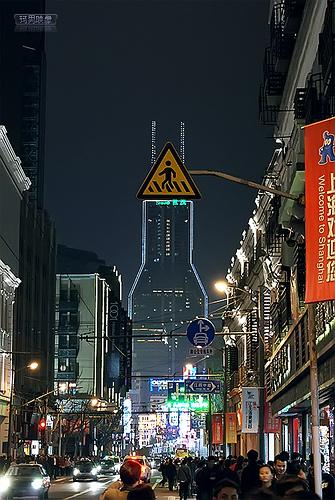Identify one unique feature or color of the sky in the image. The sky is dark blue. State the color and type of the sign on the first listed pole. Blue sign on a pole. Mention two different types of street lights found in the image. Overhead high street light, and red traffic street light. What kind of vehicle is primarily shown in the depicted scene? A small car with white lights on. In your own words, briefly describe what the main focus of the image is. An urban scene with both pedestrian and traffic street signs, and a small car present. What kind of advertisement task can be performed using this image? Product advertisement for a traffic safety sign company or a small car brand. What is the primary color of the pedestrian sign found in the given image? Yellow. Choose the appropriate statement: A) There is a person walking in the image. B) There is a dog walking in the image. C) There is no person or dog walking in the image. A) There is a person walking in the image. 